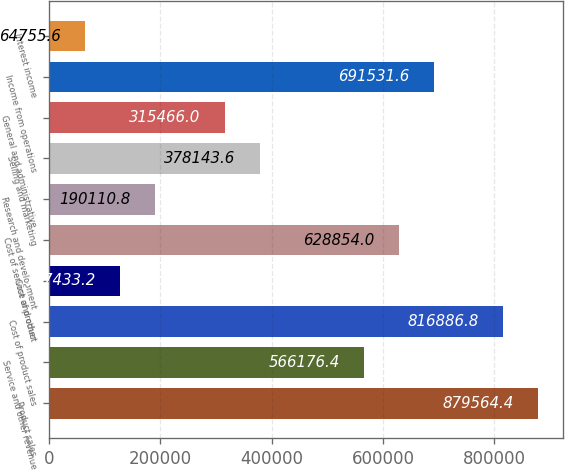Convert chart to OTSL. <chart><loc_0><loc_0><loc_500><loc_500><bar_chart><fcel>Product sales<fcel>Service and other revenue<fcel>Cost of product sales<fcel>Cost of product<fcel>Cost of service and other<fcel>Research and development<fcel>Selling and marketing<fcel>General and administrative<fcel>Income from operations<fcel>Interest income<nl><fcel>879564<fcel>566176<fcel>816887<fcel>127433<fcel>628854<fcel>190111<fcel>378144<fcel>315466<fcel>691532<fcel>64755.6<nl></chart> 